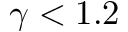Convert formula to latex. <formula><loc_0><loc_0><loc_500><loc_500>\gamma < 1 . 2</formula> 